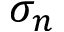Convert formula to latex. <formula><loc_0><loc_0><loc_500><loc_500>\sigma _ { n }</formula> 